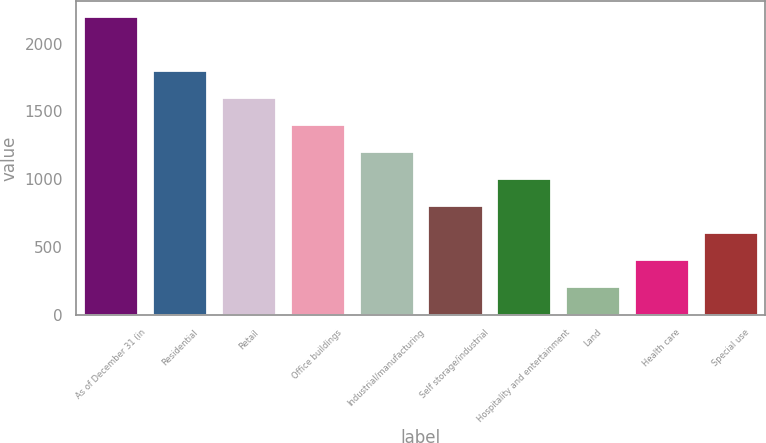<chart> <loc_0><loc_0><loc_500><loc_500><bar_chart><fcel>As of December 31 (in<fcel>Residential<fcel>Retail<fcel>Office buildings<fcel>Industrial/manufacturing<fcel>Self storage/industrial<fcel>Hospitality and entertainment<fcel>Land<fcel>Health care<fcel>Special use<nl><fcel>2204.07<fcel>1805.93<fcel>1606.86<fcel>1407.79<fcel>1208.72<fcel>810.58<fcel>1009.65<fcel>213.37<fcel>412.44<fcel>611.51<nl></chart> 